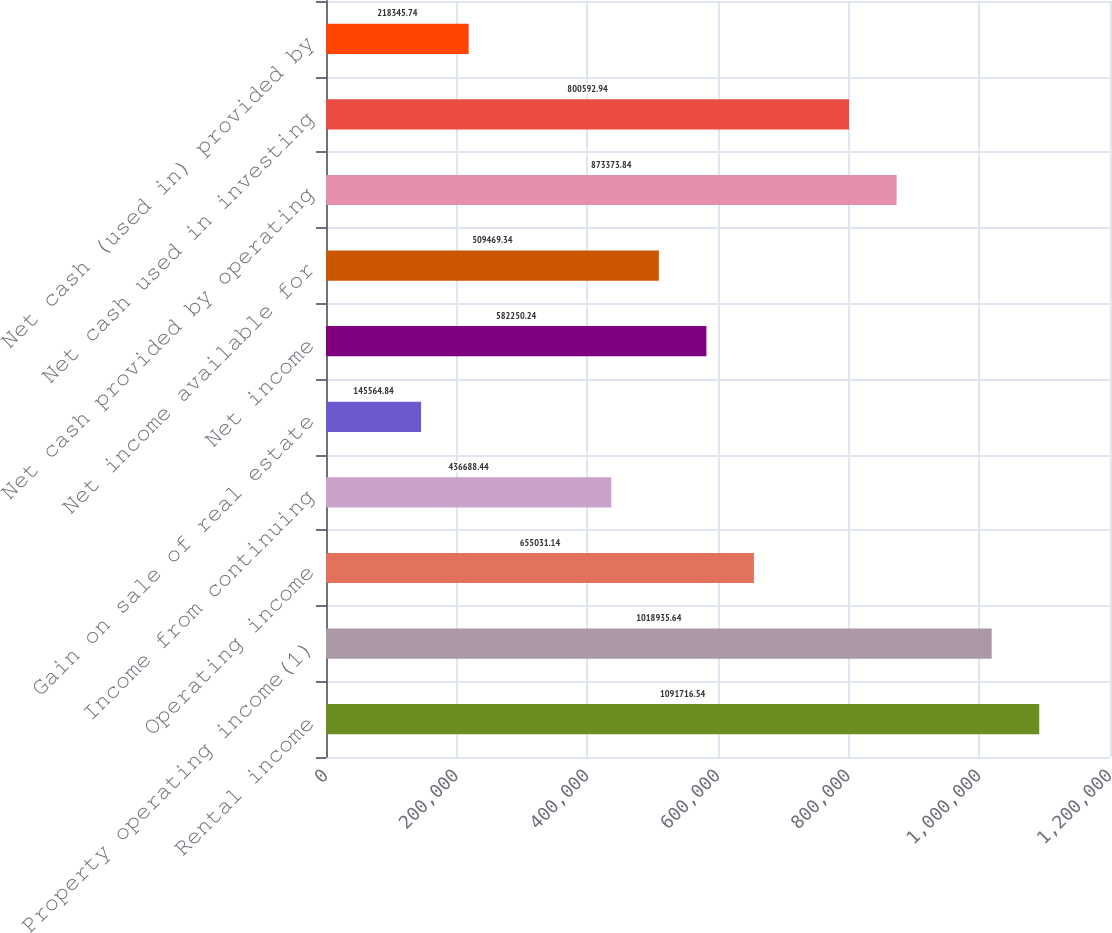<chart> <loc_0><loc_0><loc_500><loc_500><bar_chart><fcel>Rental income<fcel>Property operating income(1)<fcel>Operating income<fcel>Income from continuing<fcel>Gain on sale of real estate<fcel>Net income<fcel>Net income available for<fcel>Net cash provided by operating<fcel>Net cash used in investing<fcel>Net cash (used in) provided by<nl><fcel>1.09172e+06<fcel>1.01894e+06<fcel>655031<fcel>436688<fcel>145565<fcel>582250<fcel>509469<fcel>873374<fcel>800593<fcel>218346<nl></chart> 